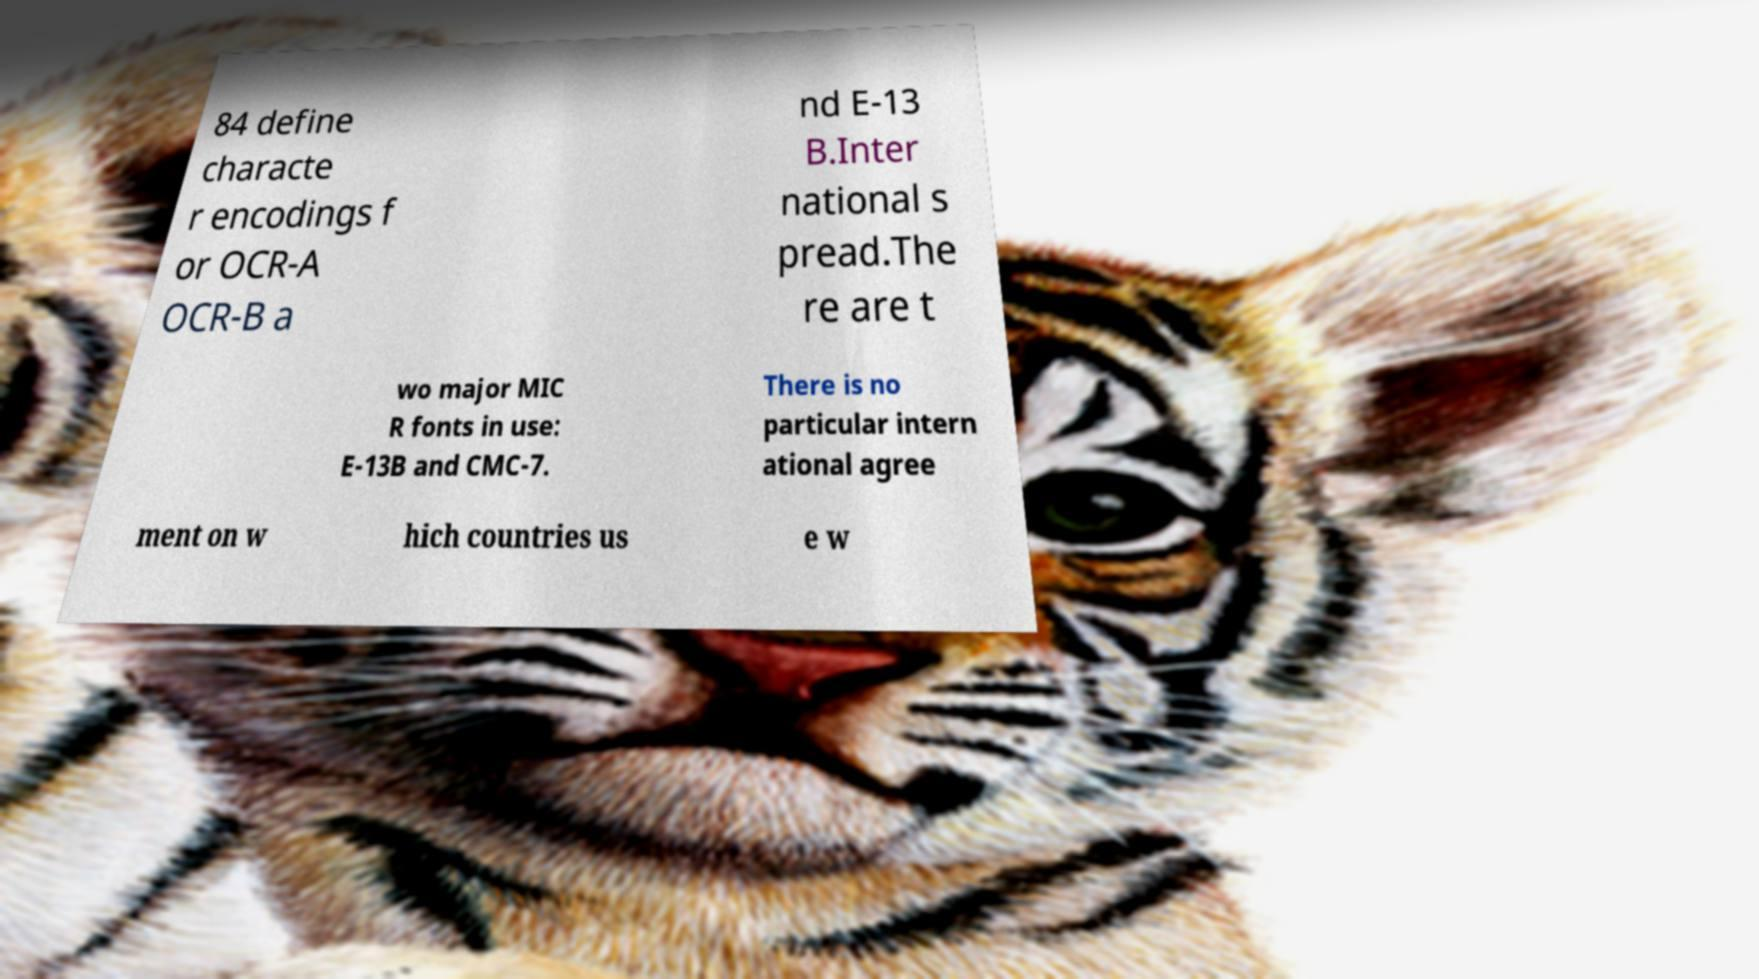For documentation purposes, I need the text within this image transcribed. Could you provide that? 84 define characte r encodings f or OCR-A OCR-B a nd E-13 B.Inter national s pread.The re are t wo major MIC R fonts in use: E-13B and CMC-7. There is no particular intern ational agree ment on w hich countries us e w 